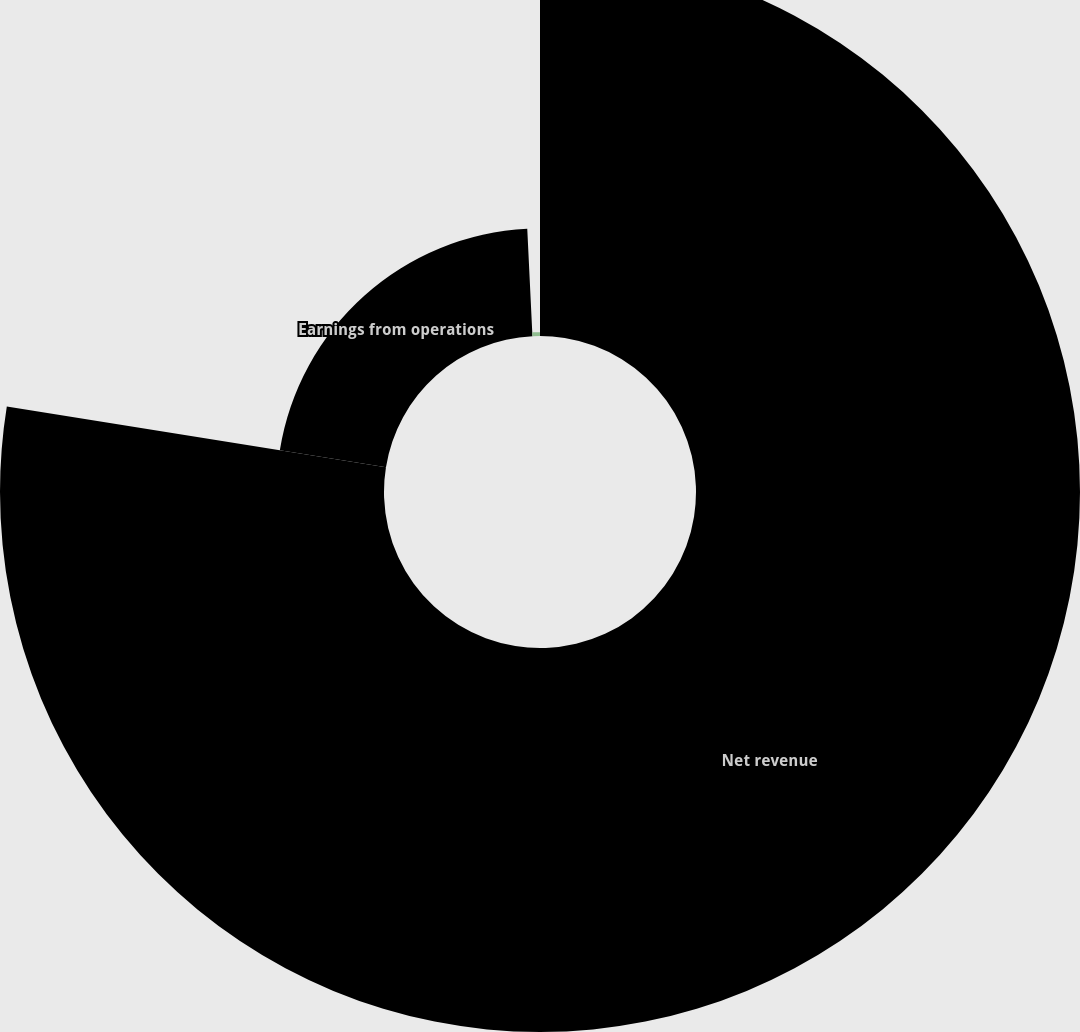Convert chart to OTSL. <chart><loc_0><loc_0><loc_500><loc_500><pie_chart><fcel>Net revenue<fcel>Earnings from operations<fcel>Earnings from operations as a<nl><fcel>77.53%<fcel>21.7%<fcel>0.77%<nl></chart> 